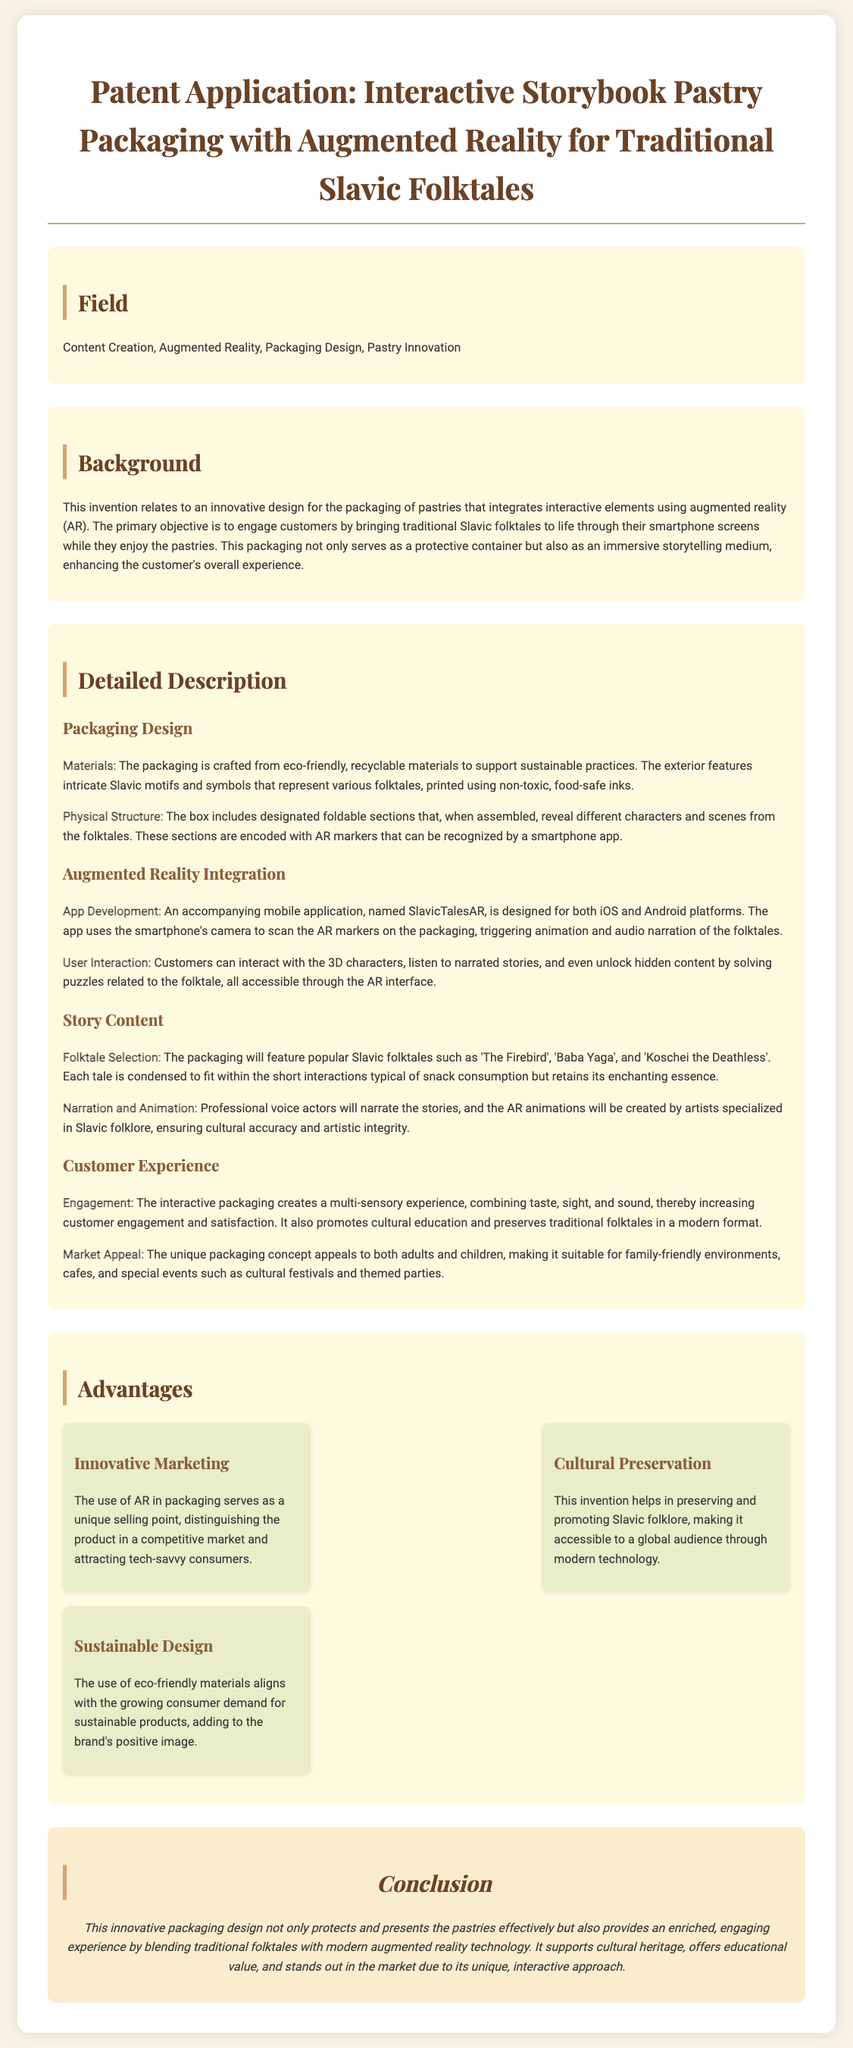What is the title of the patent application? The title is located at the top of the document and summarizes the invention's focus.
Answer: Interactive Storybook Pastry Packaging with Augmented Reality for Traditional Slavic Folktales What materials are used for the packaging? The packaging's material is specified in the detailed description, highlighting its eco-friendliness.
Answer: Eco-friendly, recyclable materials Which mobile platforms is the associated app developed for? The platforms are mentioned in the app development section, noting the compatibility of the application.
Answer: iOS and Android Name one of the popular Slavic folktales featured on the packaging. The detailed description lists specific folktales that are part of the packaging's content.
Answer: The Firebird What advantage does the AR packaging offer in terms of marketing? This advantage is detailed in the advantages section, discussing how it can position the product in the market.
Answer: Innovative Marketing How does the packaging promote cultural education? The customer experience section explains the role of the packaging in cultural preservation and education.
Answer: By preserving and promoting Slavic folklore What functionality does the "SlavicTalesAR" app provide? The functionality is outlined in the augmented reality integration section, describing how users interact with the content.
Answer: Scan AR markers, trigger animation and audio narration What is the primary objective of this invention? The background section states the main goal of the packaging design and its interactive elements.
Answer: Engage customers by bringing traditional Slavic folktales to life 